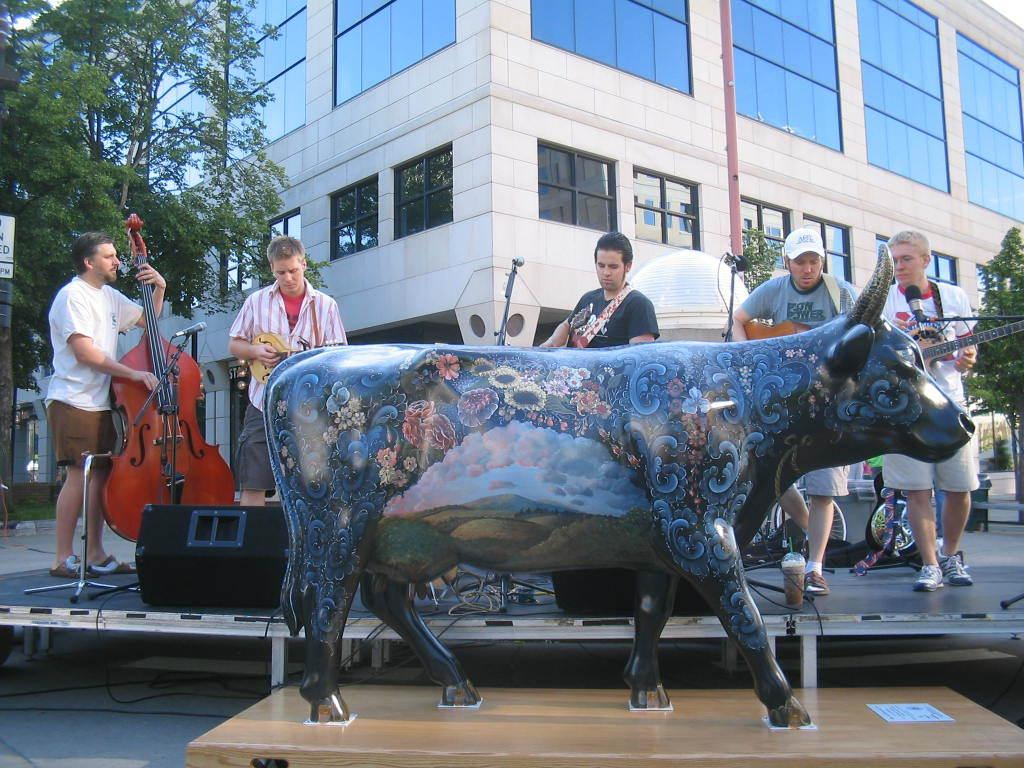What type of statue is present in the image? There is a buffalo statue in the image. What object in the image is used for amplifying sound? There is a sound box in the image. What musical instrument can be seen in the image? There is a guitar in the image. Who or what is present in the image besides objects? There are people in the image. What type of structure is visible in the image? There is a building in the image. What type of vegetation is present in the image? There are trees in the image. What language is the buffalo speaking in the image? Buffalos do not speak any language, and there is no indication of speech in the image. What achievement is the sound box celebrating in the image? The sound box is an object used for amplifying sound and is not associated with any achievements in the image. 